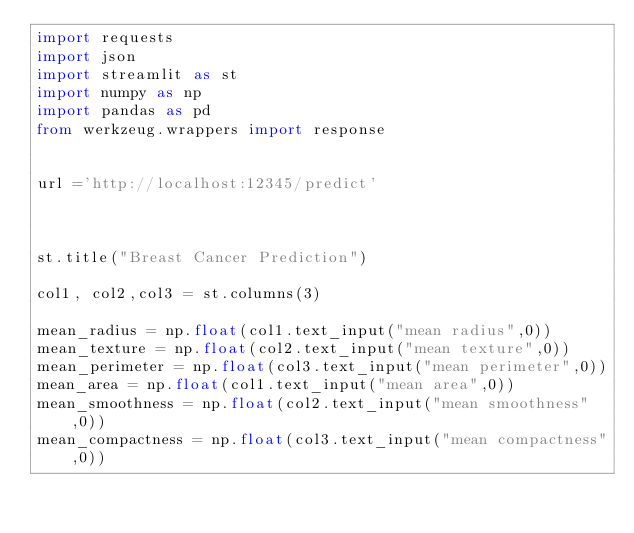Convert code to text. <code><loc_0><loc_0><loc_500><loc_500><_Python_>import requests
import json
import streamlit as st
import numpy as np
import pandas as pd
from werkzeug.wrappers import response 


url ='http://localhost:12345/predict'



st.title("Breast Cancer Prediction")

col1, col2,col3 = st.columns(3)

mean_radius = np.float(col1.text_input("mean radius",0))
mean_texture = np.float(col2.text_input("mean texture",0))
mean_perimeter = np.float(col3.text_input("mean perimeter",0))
mean_area = np.float(col1.text_input("mean area",0))
mean_smoothness = np.float(col2.text_input("mean smoothness",0))
mean_compactness = np.float(col3.text_input("mean compactness",0))</code> 